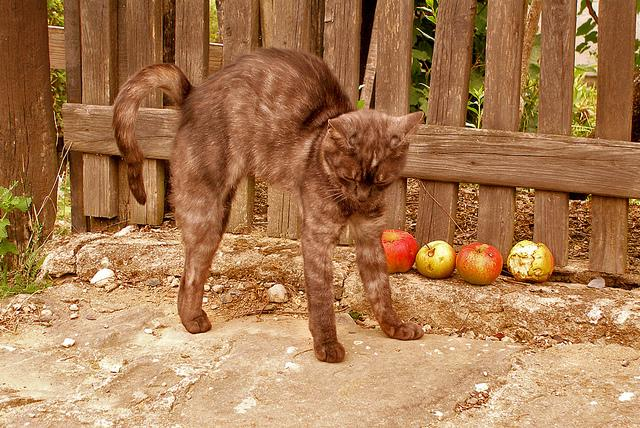What is the most popular type of apple? gala 